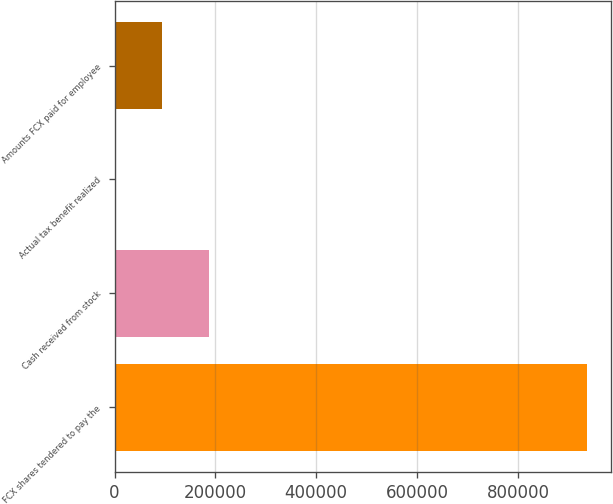Convert chart to OTSL. <chart><loc_0><loc_0><loc_500><loc_500><bar_chart><fcel>FCX shares tendered to pay the<fcel>Cash received from stock<fcel>Actual tax benefit realized<fcel>Amounts FCX paid for employee<nl><fcel>936811<fcel>187398<fcel>45<fcel>93721.6<nl></chart> 